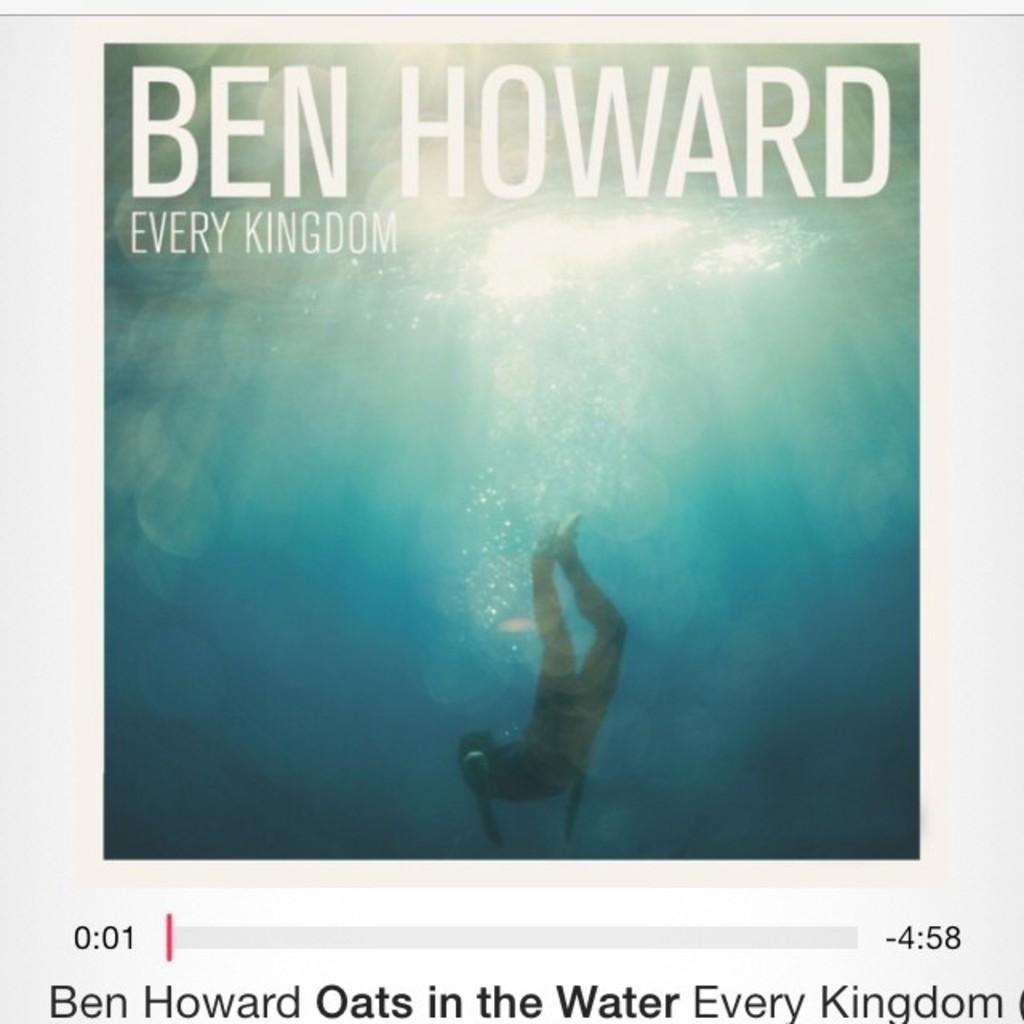What is the name of this album?
Your answer should be very brief. Every kingdom. What is the name of the artist?
Your response must be concise. Ben howard. 